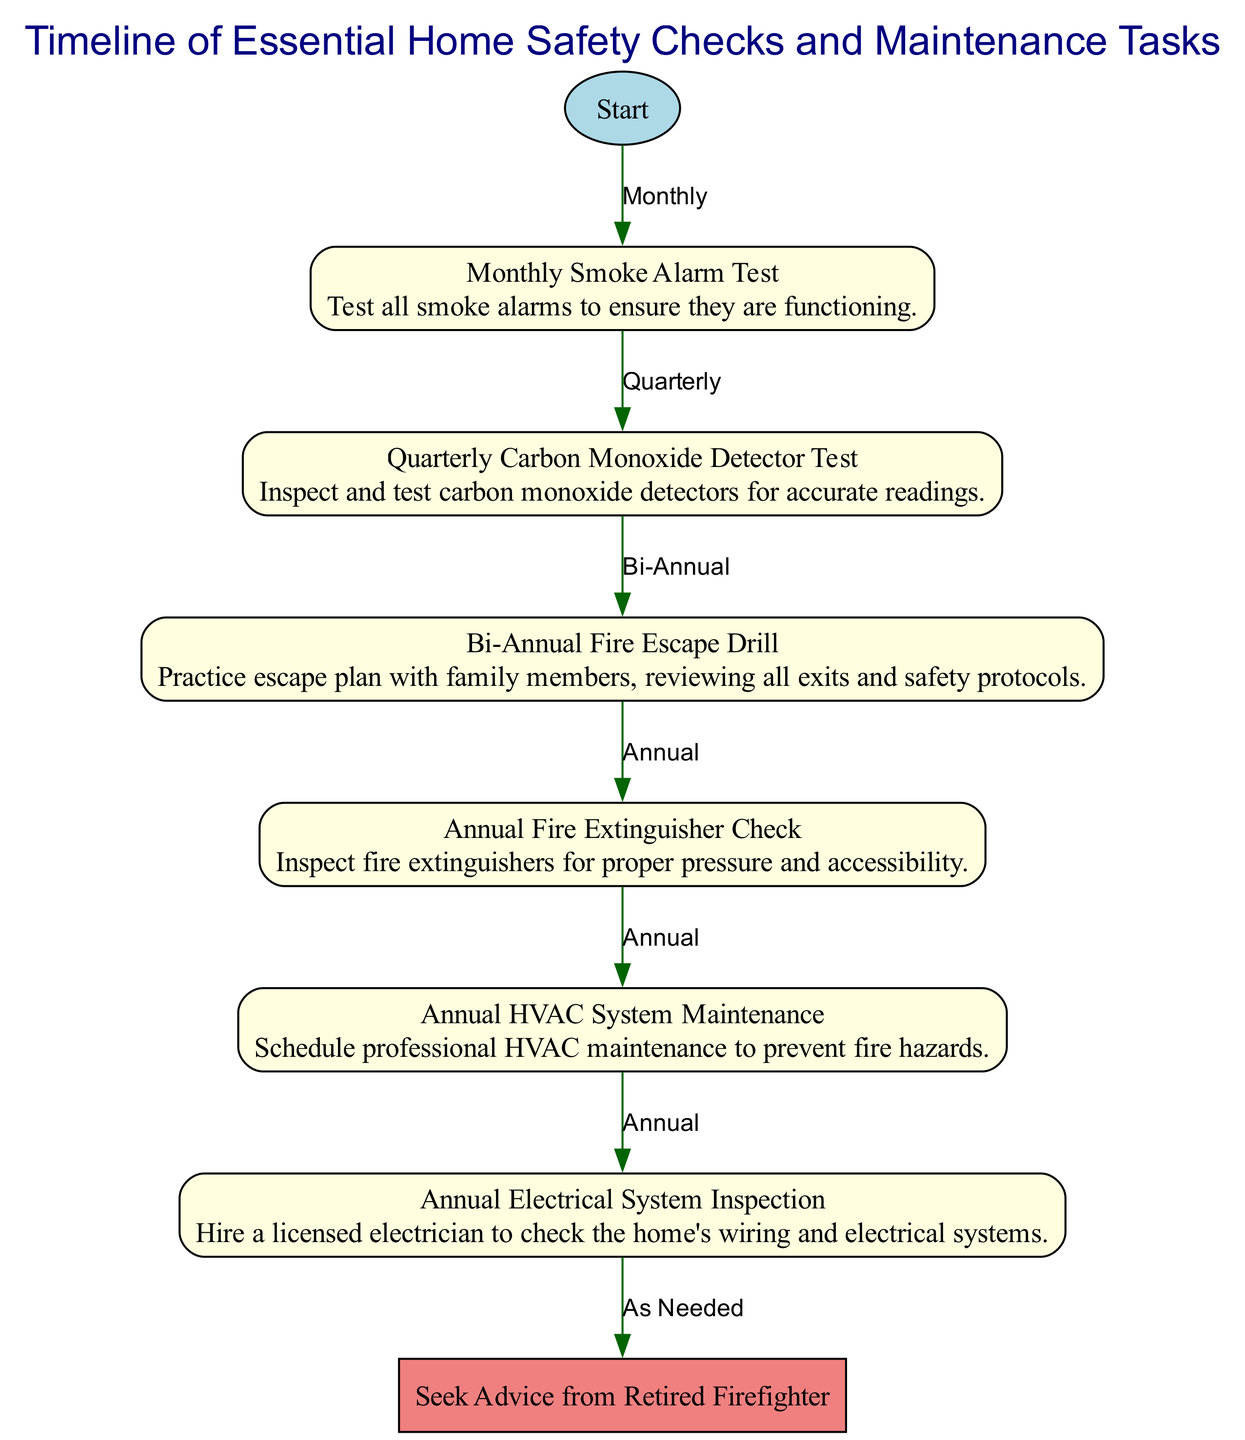What is the first task in the timeline? The first task in the timeline is indicated by the "Start" node, which leads to the "Monthly Smoke Alarm Test." Therefore, the initial safe practice to perform is to test the smoke alarms monthly.
Answer: Monthly Smoke Alarm Test How often should the carbon monoxide detector be tested? The diagram specifies that the carbon monoxide detector should be tested quarterly, as indicated by the label connecting the "Monthly Smoke Alarm Test" to the "Quarterly Carbon Monoxide Detector Test."
Answer: Quarterly What is the relationship between the fire extinguisher check and HVAC maintenance? The diagram shows a direct link from the "Annual Fire Extinguisher Check" to the "Annual HVAC System Maintenance," indicating that they are scheduled on an annual basis, one after the other.
Answer: Annual How many total nodes are represented in the diagram? By counting the nodes listed in the data, we find there are eight nodes, including the "Start" node and all subsequent tasks like smoke alarms, carbon monoxide detection, etc.
Answer: Eight Which task requires consulting a retired firefighter? The node labeled "Seek Advice from Retired Firefighter" directly follows the "Annual Electrical System Inspection" node, indicating that this step is taken as needed after the electrical inspection.
Answer: Seek Advice from Retired Firefighter What maintenance task is performed bi-annually? According to the diagram, the "Bi-Annual Fire Escape Drill" is the designated task performed twice a year after testing the carbon monoxide detector.
Answer: Bi-Annual Fire Escape Drill If a smoke alarm is tested monthly, how often should all other tasks be checked? Following the flow from the "Monthly Smoke Alarm Test," the diagram outlines that carbon monoxide detectors are checked quarterly, and other tasks like fire extinguisher checks, HVAC maintenance, and electrical system inspection follow an annual schedule. So the pattern is monthly for smoke alarms, quarterly for carbon monoxide detectors, and then annual for the rest.
Answer: Monthly, Quarterly, Annual What does the diagram suggest to do after completing the electrical check? The diagram clearly indicates that after the "Annual Electrical System Inspection," the subsequent step is to "Seek Advice from Retired Firefighter," indicating a consultation for further guidance after completing the inspection.
Answer: Seek Advice from Retired Firefighter 